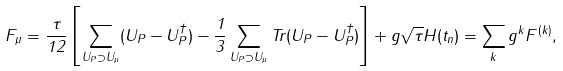<formula> <loc_0><loc_0><loc_500><loc_500>F _ { \mu } = \frac { \tau } { 1 2 } \left [ \sum _ { U _ { P } \supset U _ { \mu } } ( U _ { P } - U _ { P } ^ { \dagger } ) - \frac { 1 } { 3 } \sum _ { U _ { P } \supset U _ { \mu } } T r ( U _ { P } - U _ { P } ^ { \dagger } ) \right ] + g \sqrt { \tau } H ( t _ { n } ) = \sum _ { k } g ^ { k } F ^ { ( k ) } , \\</formula> 